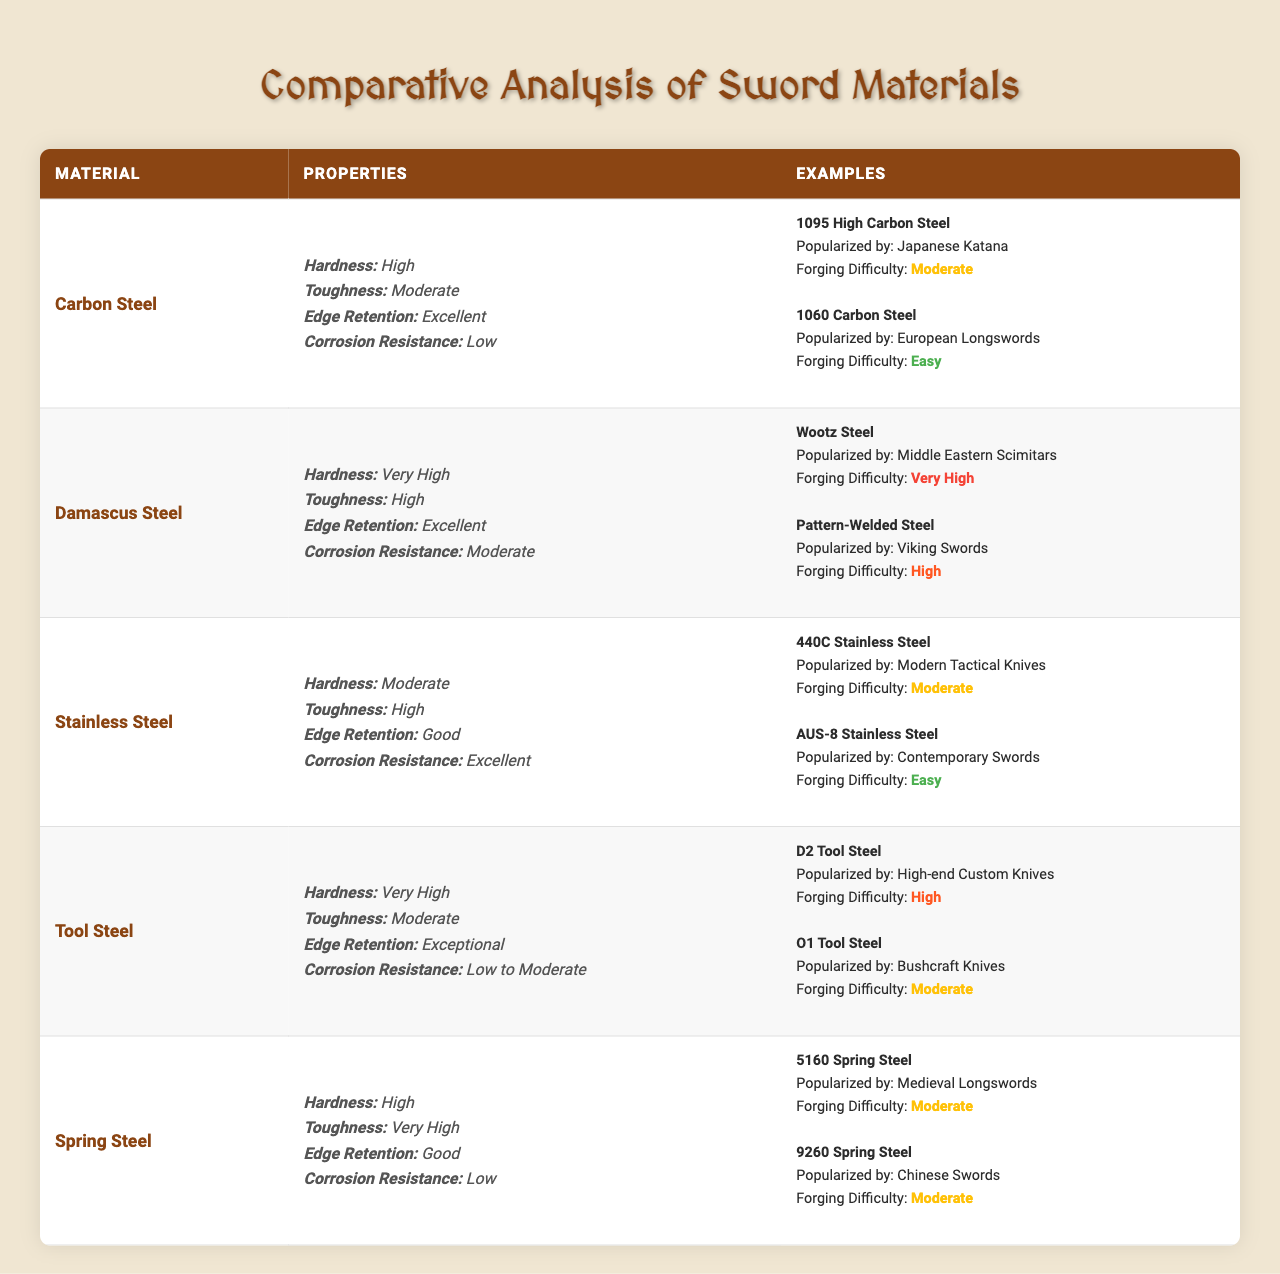What is the material with the highest corrosion resistance? Reviewing the properties listed, Stainless Steel has an "Excellent" corrosion resistance rating, which is higher than any other material.
Answer: Stainless Steel Which sword material has both very high hardness and high toughness? Observing the properties, Tool Steel has "Very High" hardness and "Moderate" toughness, while Damascus Steel has "Very High" hardness and "High" toughness, making it the material that fits both these categories.
Answer: Damascus Steel Are there any sword materials with low corrosion resistance? Yes, both Carbon Steel and Tool Steel have "Low" or "Low to Moderate" corrosion resistance as indicated in their properties.
Answer: Yes Which material is known for exceptional edge retention? The table shows that Tool Steel has "Exceptional" edge retention, which is the highest rating listed for this property.
Answer: Tool Steel What materials are popularized by European weapons? The table shows that 1060 Carbon Steel is popularized by European Longswords, indicating European influence in its use.
Answer: 1060 Carbon Steel How do the edge retention ratings of Damascus Steel and Spring Steel compare? Damascus Steel has "Excellent" edge retention, while Spring Steel has "Good" edge retention, indicating that Damascus Steel retains its edge better than Spring Steel.
Answer: Damascus Steel has better edge retention Which sword material has the most examples listed in the table? By counting, both Carbon Steel and Damascus Steel have two examples each, whereas the other materials have one example each. Thus, these two materials tie for the most examples.
Answer: Carbon Steel and Damascus Steel If a swordsmith is looking for a material with high toughness and excellent corrosion resistance, which material should they choose? Stainless Steel has "High" toughness and "Excellent" corrosion resistance, making it a suitable option for a swordsmith looking for these specific properties.
Answer: Stainless Steel Is Wootz Steel more difficult to forge than 440C Stainless Steel? Yes, Wootz Steel has a "Very High" forging difficulty compared to 440C Stainless Steel, which is rated as "Moderate."
Answer: Yes What is the correlation between toughness and edge retention for Carbon Steel? Carbon Steel has "Moderate" toughness and "Excellent" edge retention. This indicates that while it may not be the toughest material, its ability to maintain a sharp edge is very high.
Answer: Moderate toughness, excellent edge retention Which materials have moderate forging difficulty? Both 1060 Carbon Steel, AUS-8 Stainless Steel, and 5160 Spring Steel are listed as having "Moderate" forging difficulty. This shows that several materials can be forged with similar levels of difficulty.
Answer: 1060 Carbon Steel, AUS-8 Stainless Steel, 5160 Spring Steel 